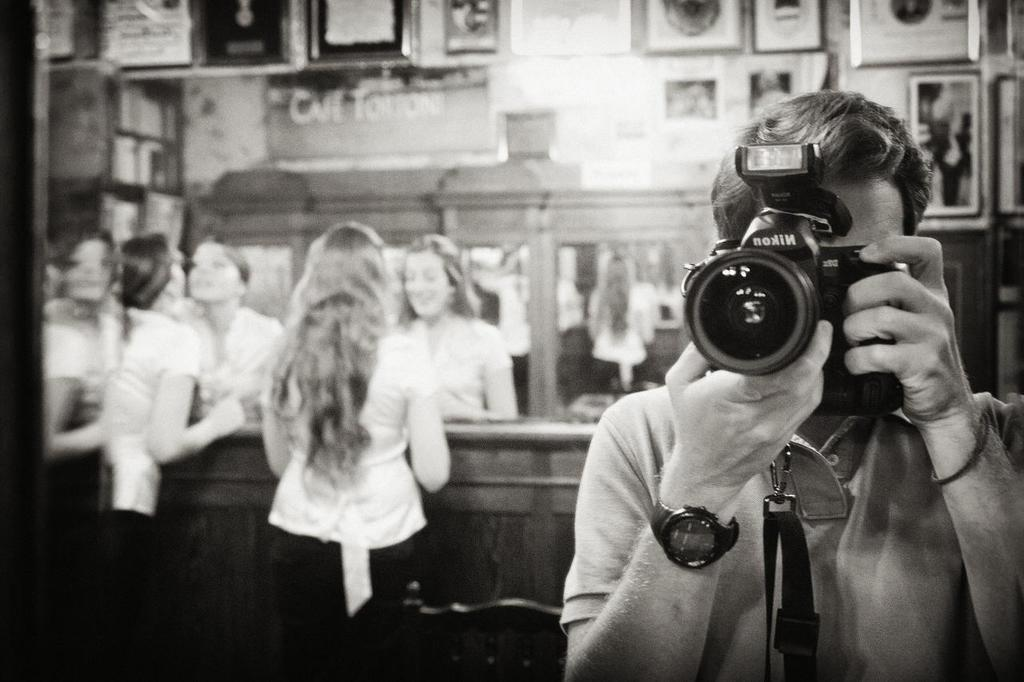What is the person in the image holding? The person is holding a camera in the image. How is the person holding the camera? The person is holding the camera with both hands. What are the two women in the image doing? The two women are standing in the image and looking into a mirror. What type of silk fabric is draped over the stick in the image? There is no silk fabric or stick present in the image. 